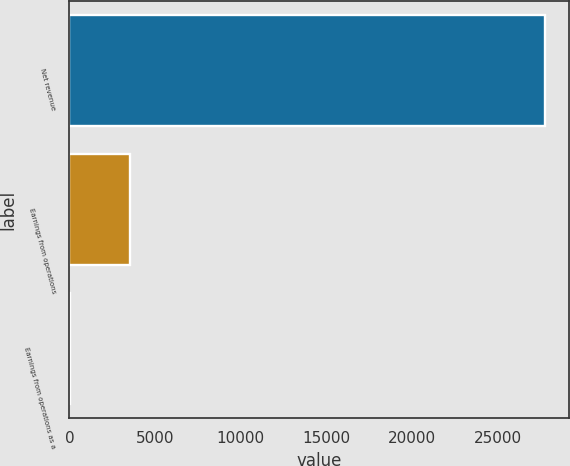<chart> <loc_0><loc_0><loc_500><loc_500><bar_chart><fcel>Net revenue<fcel>Earnings from operations<fcel>Earnings from operations as a<nl><fcel>27779<fcel>3569<fcel>12.8<nl></chart> 